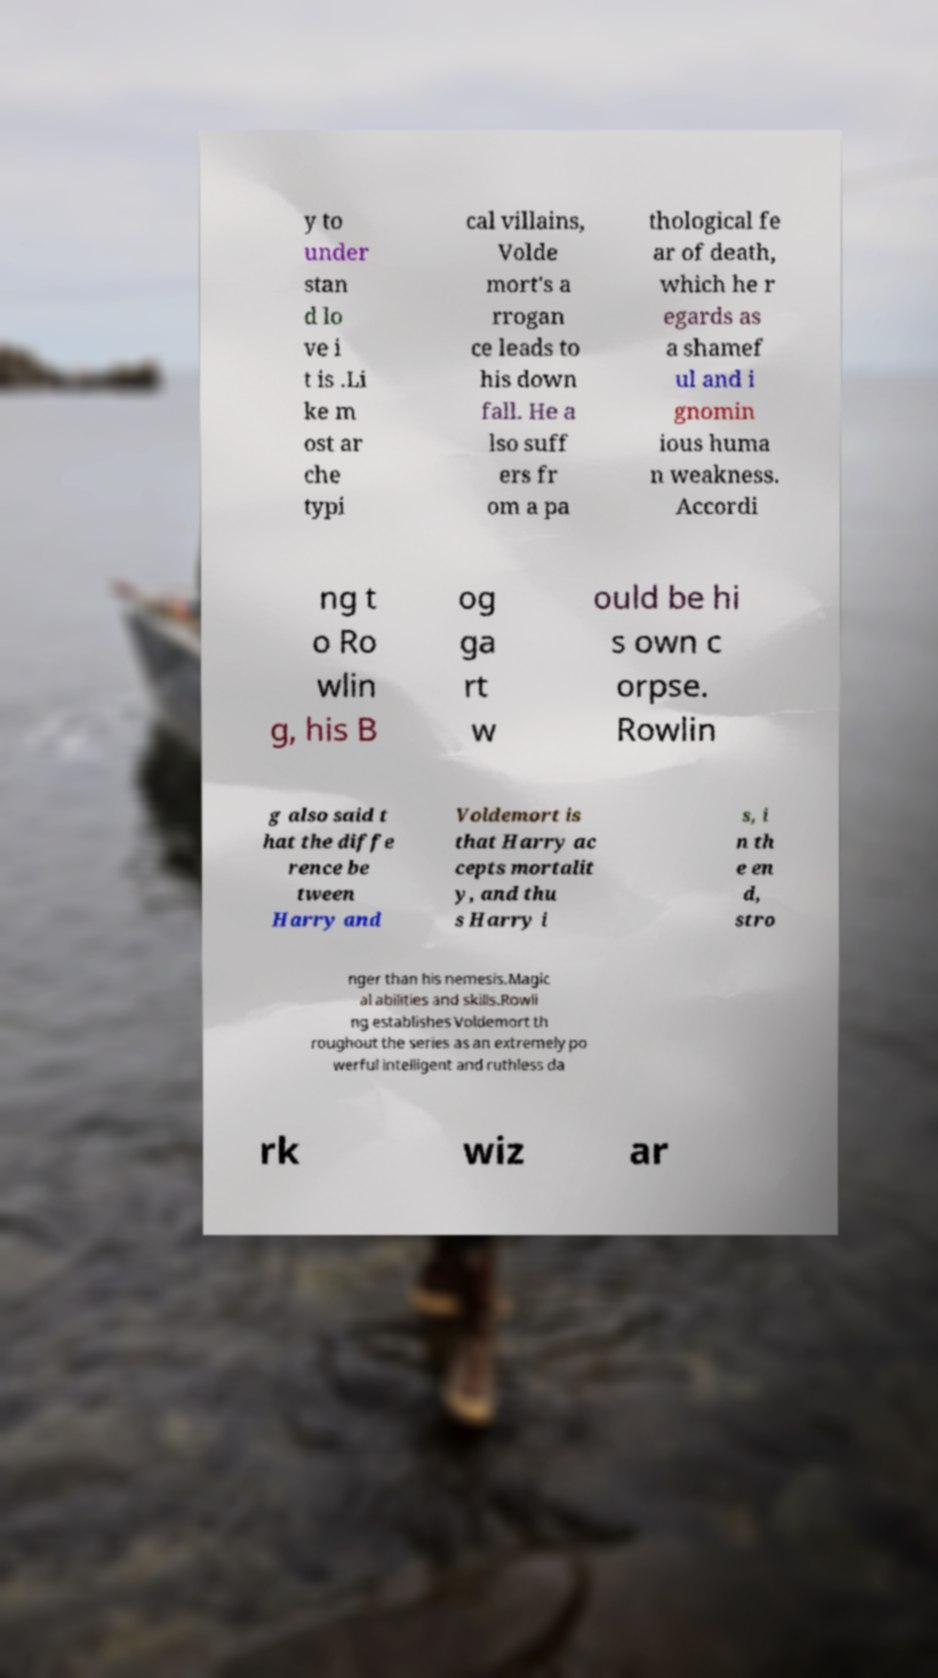I need the written content from this picture converted into text. Can you do that? y to under stan d lo ve i t is .Li ke m ost ar che typi cal villains, Volde mort's a rrogan ce leads to his down fall. He a lso suff ers fr om a pa thological fe ar of death, which he r egards as a shamef ul and i gnomin ious huma n weakness. Accordi ng t o Ro wlin g, his B og ga rt w ould be hi s own c orpse. Rowlin g also said t hat the diffe rence be tween Harry and Voldemort is that Harry ac cepts mortalit y, and thu s Harry i s, i n th e en d, stro nger than his nemesis.Magic al abilities and skills.Rowli ng establishes Voldemort th roughout the series as an extremely po werful intelligent and ruthless da rk wiz ar 